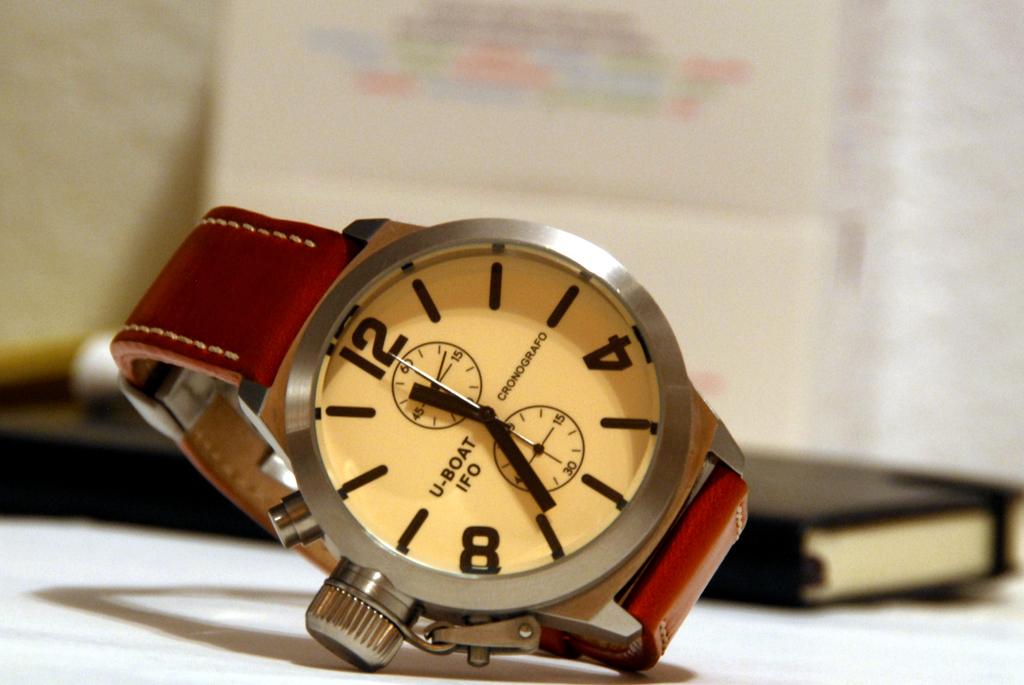What kind of watch is that?
Your response must be concise. Answering does not require reading text in the image. What is under u-boat?
Your response must be concise. Ifo. 